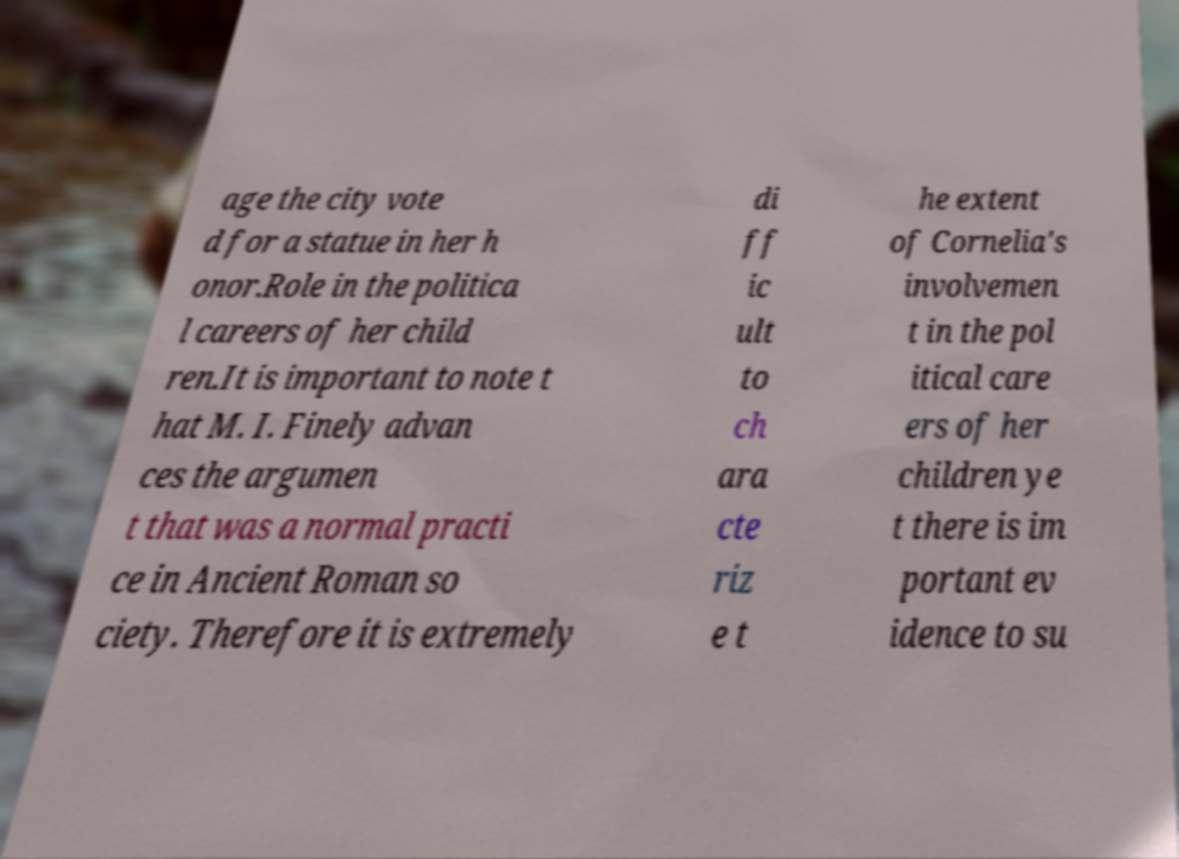For documentation purposes, I need the text within this image transcribed. Could you provide that? age the city vote d for a statue in her h onor.Role in the politica l careers of her child ren.It is important to note t hat M. I. Finely advan ces the argumen t that was a normal practi ce in Ancient Roman so ciety. Therefore it is extremely di ff ic ult to ch ara cte riz e t he extent of Cornelia's involvemen t in the pol itical care ers of her children ye t there is im portant ev idence to su 